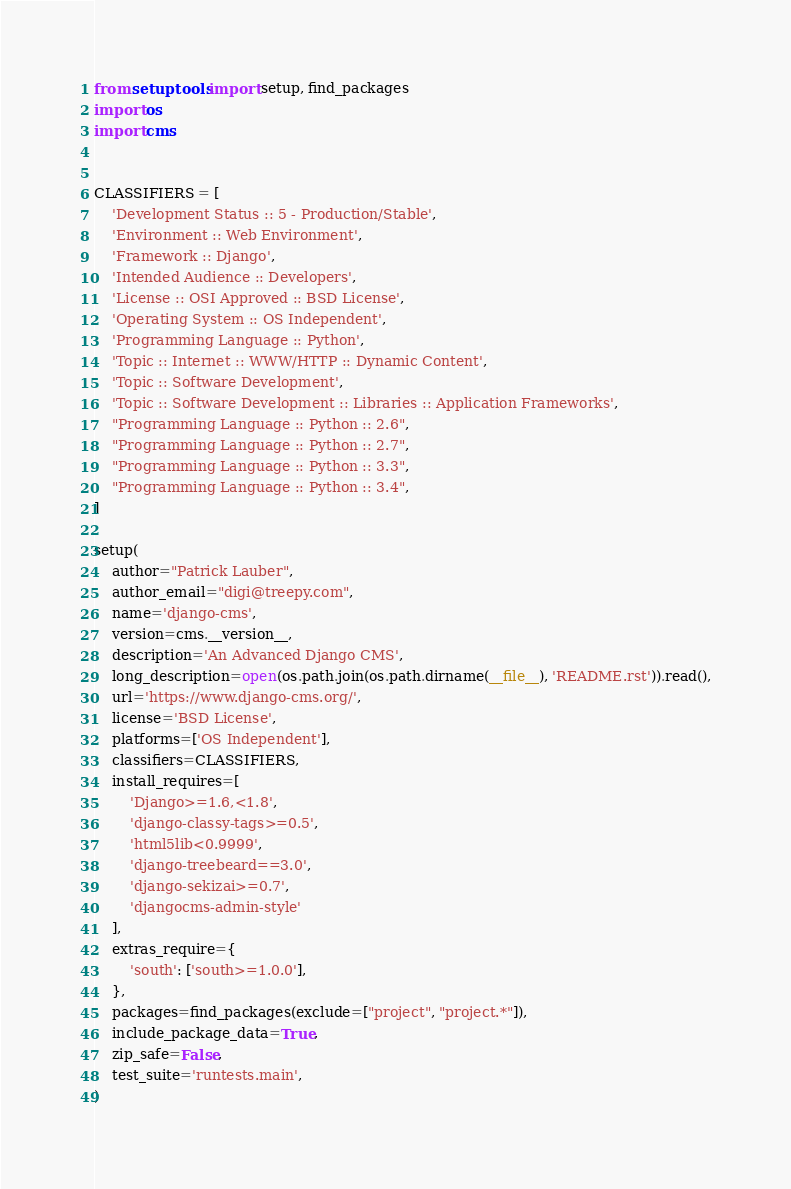Convert code to text. <code><loc_0><loc_0><loc_500><loc_500><_Python_>from setuptools import setup, find_packages
import os
import cms


CLASSIFIERS = [
    'Development Status :: 5 - Production/Stable',
    'Environment :: Web Environment',
    'Framework :: Django',
    'Intended Audience :: Developers',
    'License :: OSI Approved :: BSD License',
    'Operating System :: OS Independent',
    'Programming Language :: Python',
    'Topic :: Internet :: WWW/HTTP :: Dynamic Content',
    'Topic :: Software Development',
    'Topic :: Software Development :: Libraries :: Application Frameworks',
    "Programming Language :: Python :: 2.6",
    "Programming Language :: Python :: 2.7",
    "Programming Language :: Python :: 3.3",
    "Programming Language :: Python :: 3.4",
]

setup(
    author="Patrick Lauber",
    author_email="digi@treepy.com",
    name='django-cms',
    version=cms.__version__,
    description='An Advanced Django CMS',
    long_description=open(os.path.join(os.path.dirname(__file__), 'README.rst')).read(),
    url='https://www.django-cms.org/',
    license='BSD License',
    platforms=['OS Independent'],
    classifiers=CLASSIFIERS,
    install_requires=[
        'Django>=1.6,<1.8',
        'django-classy-tags>=0.5',
        'html5lib<0.9999',
        'django-treebeard==3.0',
        'django-sekizai>=0.7',
        'djangocms-admin-style'
    ],
    extras_require={
        'south': ['south>=1.0.0'],
    },
    packages=find_packages(exclude=["project", "project.*"]),
    include_package_data=True,
    zip_safe=False,
    test_suite='runtests.main',
)
</code> 